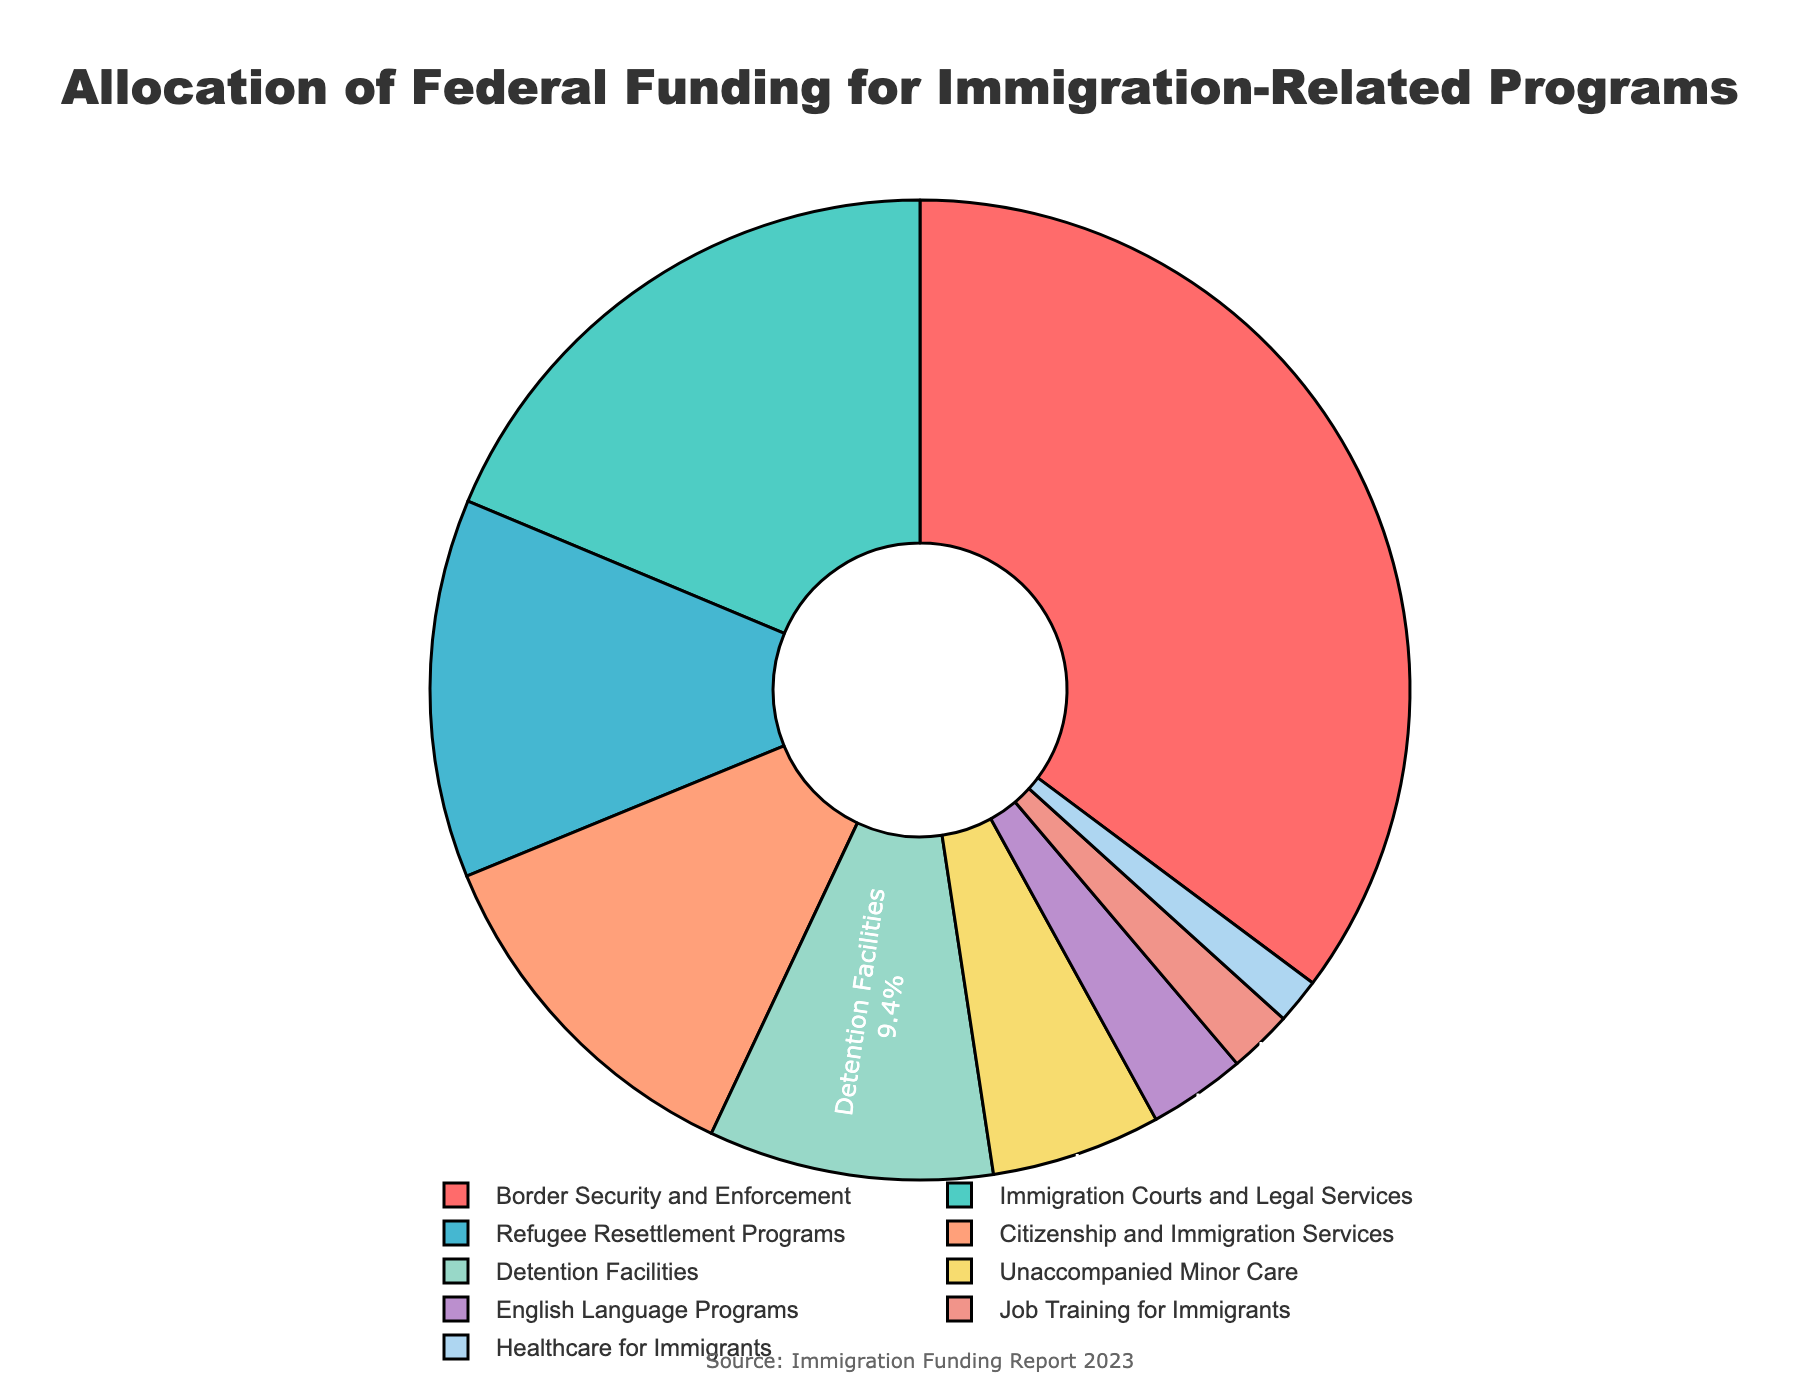What's the largest allocation of federal funding in the pie chart? The largest allocation can be determined by finding the category with the highest percentage. Border Security and Enforcement has the highest percentage at 35.2%.
Answer: Border Security and Enforcement What's the combined percentage of federal funding for Immigration Courts and Legal Services and Citizenship and Immigration Services? Add the percentages for both categories: Immigration Courts and Legal Services (18.7%) + Citizenship and Immigration Services (11.8%) = 30.5%.
Answer: 30.5% Which category has the smallest allocation of federal funding? The smallest allocation is the category with the lowest percentage, which is Healthcare for Immigrants at 1.5%.
Answer: Healthcare for Immigrants How does the funding for Detention Facilities compare to that for Refugee Resettlement Programs? Compare the percentages: Detention Facilities (9.4%) is less than Refugee Resettlement Programs (12.5%).
Answer: Less What is the total percentage allocated to Unaccompanied Minor Care and English Language Programs combined? Add the percentages for both categories: Unaccompanied Minor Care (5.6%) + English Language Programs (3.2%) = 8.8%.
Answer: 8.8% Which categories have a funding allocation greater than 10%? Categories with a greater than 10% allocation are identified as Border Security and Enforcement (35.2%), Immigration Courts and Legal Services (18.7%), Refugee Resettlement Programs (12.5%), and Citizenship and Immigration Services (11.8%).
Answer: Border Security and Enforcement, Immigration Courts and Legal Services, Refugee Resettlement Programs, Citizenship and Immigration Services What is the difference in funding allocation between Job Training for Immigrants and Healthcare for Immigrants? Subtract the percentages: Job Training for Immigrants (2.1%) - Healthcare for Immigrants (1.5%) = 0.6%.
Answer: 0.6% Which funding category is depicted in blue? The category depicted in blue is Citizenship and Immigration Services. This is confirmed by cross-referencing the chart's colors with the visual description.
Answer: Citizenship and Immigration Services 